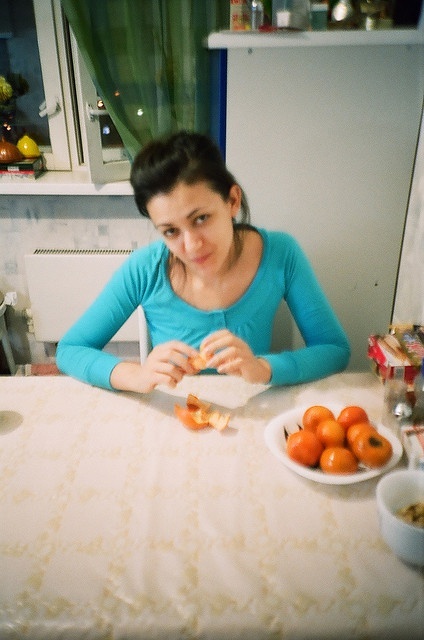Describe the objects in this image and their specific colors. I can see dining table in black, lightgray, and tan tones, people in black, teal, tan, and lightblue tones, bowl in black, darkgray, gray, and lightgray tones, bowl in black, lightgray, and tan tones, and orange in black, red, brown, and orange tones in this image. 